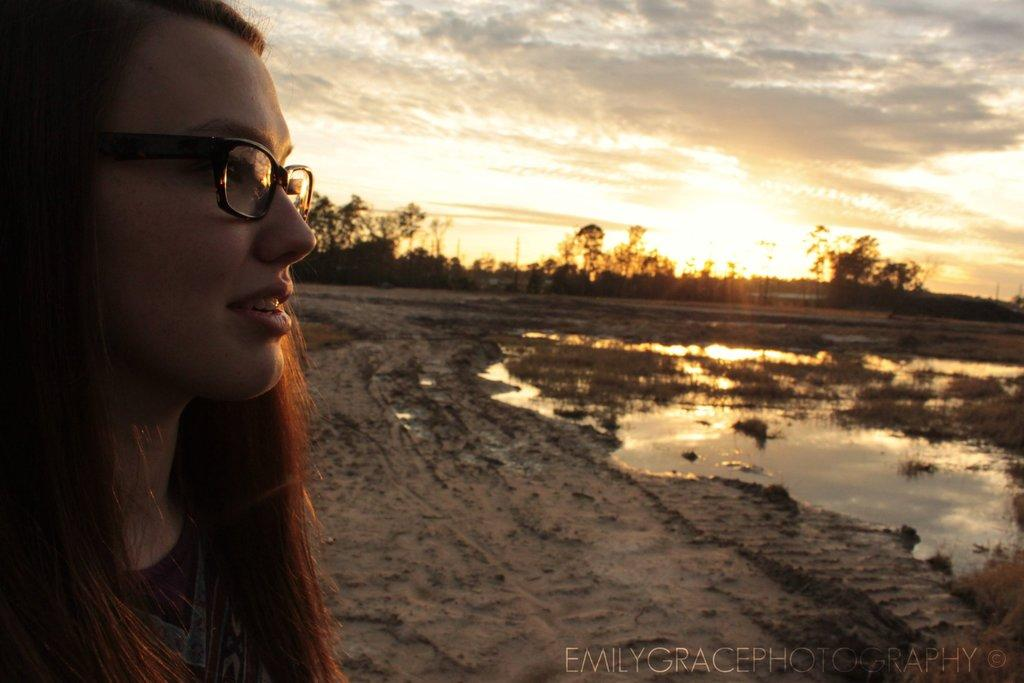What is located on the left side of the image? There is a woman on the left side of the image. What type of terrain can be seen in the background of the image? There is sand and water in the background of the image. What structures are visible in the background of the image? There are poles in the background of the image. What type of vegetation is present in the background of the image? There are trees in the background of the image. What is visible in the sky in the background of the image? There are clouds in the sky in the background of the image. What type of plastic is being used to play chess in the image? There is no plastic or chess game present in the image. 